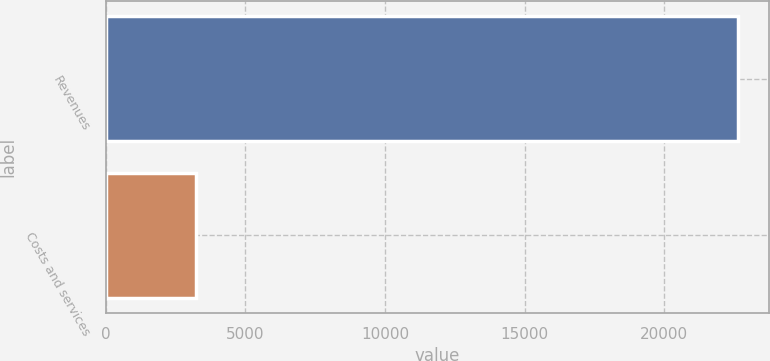Convert chart. <chart><loc_0><loc_0><loc_500><loc_500><bar_chart><fcel>Revenues<fcel>Costs and services<nl><fcel>22627<fcel>3246<nl></chart> 